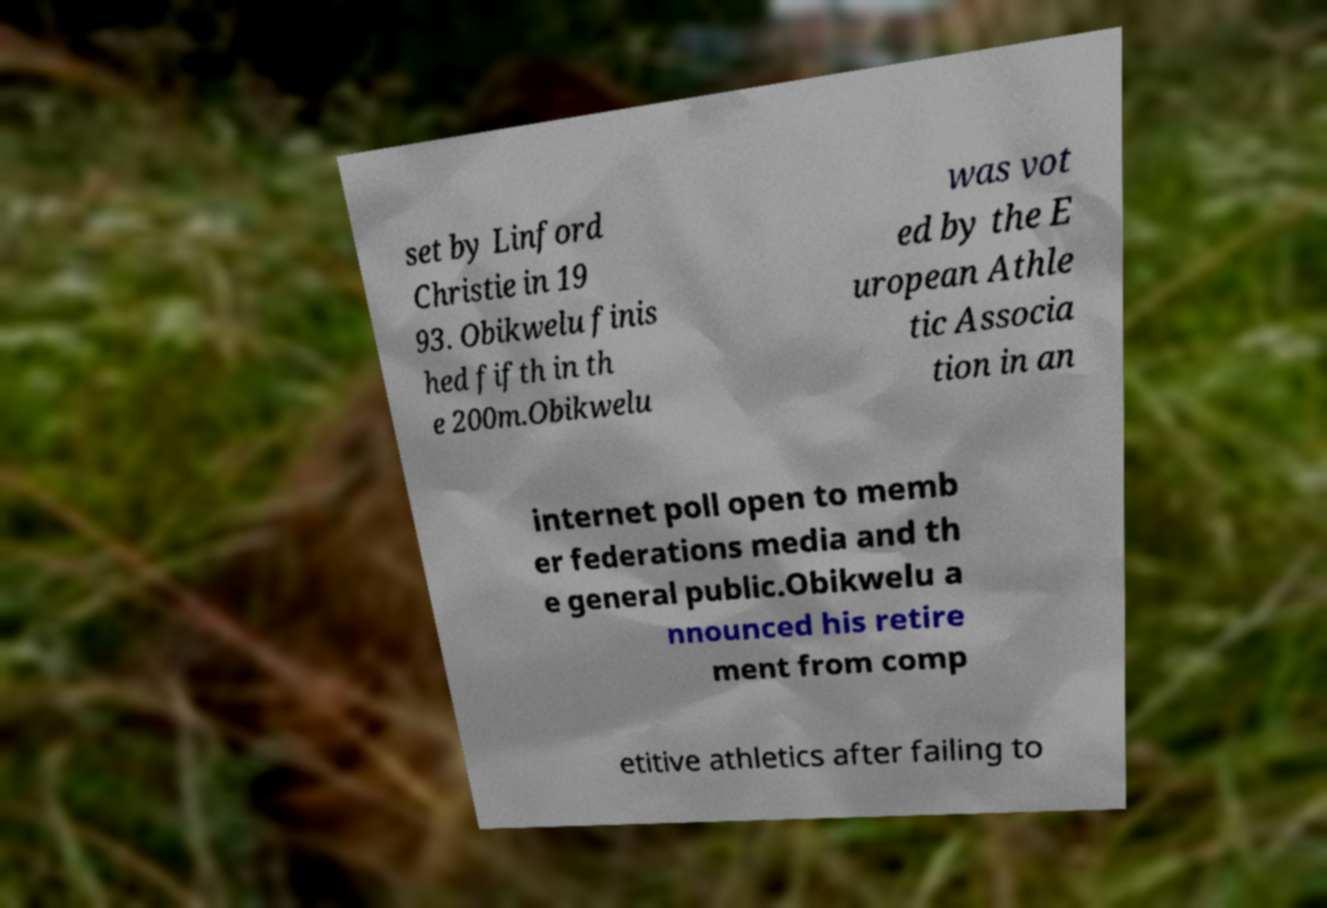Please read and relay the text visible in this image. What does it say? set by Linford Christie in 19 93. Obikwelu finis hed fifth in th e 200m.Obikwelu was vot ed by the E uropean Athle tic Associa tion in an internet poll open to memb er federations media and th e general public.Obikwelu a nnounced his retire ment from comp etitive athletics after failing to 